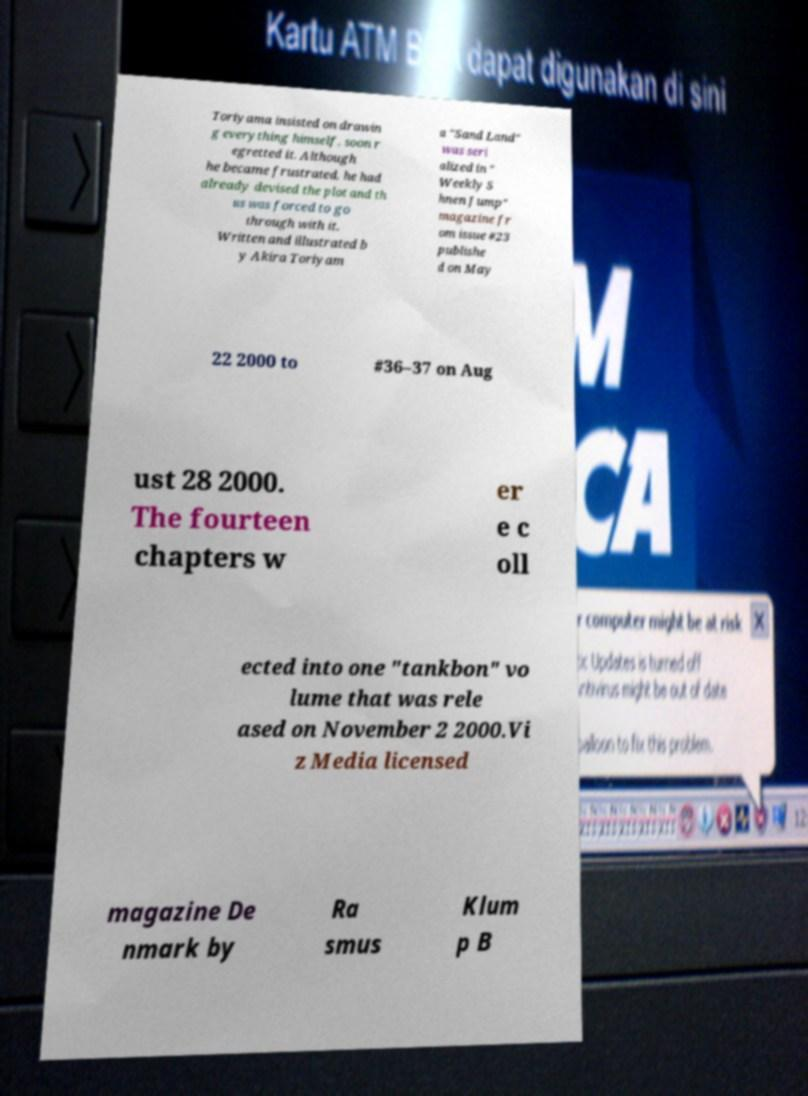For documentation purposes, I need the text within this image transcribed. Could you provide that? Toriyama insisted on drawin g everything himself, soon r egretted it. Although he became frustrated, he had already devised the plot and th us was forced to go through with it. Written and illustrated b y Akira Toriyam a "Sand Land" was seri alized in " Weekly S hnen Jump" magazine fr om issue #23 publishe d on May 22 2000 to #36–37 on Aug ust 28 2000. The fourteen chapters w er e c oll ected into one "tankbon" vo lume that was rele ased on November 2 2000.Vi z Media licensed magazine De nmark by Ra smus Klum p B 